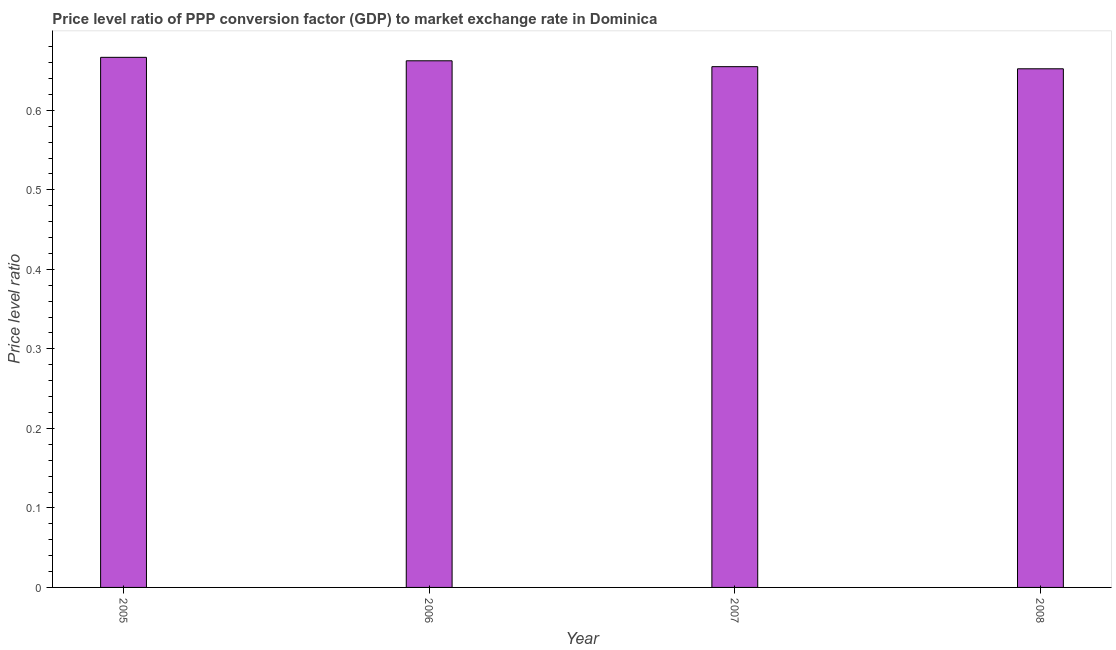Does the graph contain any zero values?
Offer a very short reply. No. Does the graph contain grids?
Your answer should be very brief. No. What is the title of the graph?
Your answer should be compact. Price level ratio of PPP conversion factor (GDP) to market exchange rate in Dominica. What is the label or title of the Y-axis?
Your answer should be compact. Price level ratio. What is the price level ratio in 2007?
Give a very brief answer. 0.65. Across all years, what is the maximum price level ratio?
Give a very brief answer. 0.67. Across all years, what is the minimum price level ratio?
Your answer should be compact. 0.65. What is the sum of the price level ratio?
Your answer should be compact. 2.64. What is the difference between the price level ratio in 2007 and 2008?
Offer a very short reply. 0. What is the average price level ratio per year?
Your response must be concise. 0.66. What is the median price level ratio?
Make the answer very short. 0.66. In how many years, is the price level ratio greater than 0.56 ?
Provide a short and direct response. 4. Is the difference between the price level ratio in 2005 and 2006 greater than the difference between any two years?
Provide a short and direct response. No. What is the difference between the highest and the second highest price level ratio?
Make the answer very short. 0. Is the sum of the price level ratio in 2005 and 2007 greater than the maximum price level ratio across all years?
Your answer should be very brief. Yes. What is the difference between the highest and the lowest price level ratio?
Provide a short and direct response. 0.01. In how many years, is the price level ratio greater than the average price level ratio taken over all years?
Offer a terse response. 2. How many bars are there?
Provide a succinct answer. 4. Are all the bars in the graph horizontal?
Your answer should be compact. No. How many years are there in the graph?
Your answer should be very brief. 4. What is the difference between two consecutive major ticks on the Y-axis?
Your answer should be very brief. 0.1. Are the values on the major ticks of Y-axis written in scientific E-notation?
Offer a very short reply. No. What is the Price level ratio of 2005?
Provide a succinct answer. 0.67. What is the Price level ratio of 2006?
Ensure brevity in your answer.  0.66. What is the Price level ratio in 2007?
Provide a succinct answer. 0.65. What is the Price level ratio in 2008?
Provide a succinct answer. 0.65. What is the difference between the Price level ratio in 2005 and 2006?
Keep it short and to the point. 0. What is the difference between the Price level ratio in 2005 and 2007?
Make the answer very short. 0.01. What is the difference between the Price level ratio in 2005 and 2008?
Provide a short and direct response. 0.01. What is the difference between the Price level ratio in 2006 and 2007?
Offer a terse response. 0.01. What is the difference between the Price level ratio in 2006 and 2008?
Offer a very short reply. 0.01. What is the difference between the Price level ratio in 2007 and 2008?
Offer a very short reply. 0. What is the ratio of the Price level ratio in 2006 to that in 2007?
Make the answer very short. 1.01. What is the ratio of the Price level ratio in 2007 to that in 2008?
Offer a very short reply. 1. 